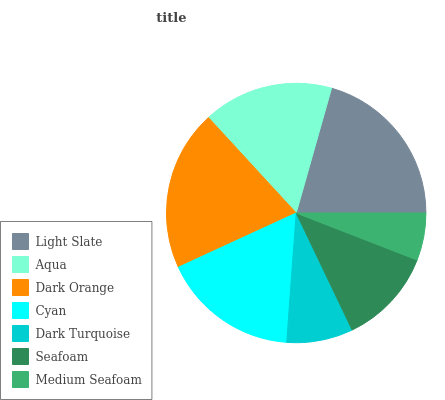Is Medium Seafoam the minimum?
Answer yes or no. Yes. Is Light Slate the maximum?
Answer yes or no. Yes. Is Aqua the minimum?
Answer yes or no. No. Is Aqua the maximum?
Answer yes or no. No. Is Light Slate greater than Aqua?
Answer yes or no. Yes. Is Aqua less than Light Slate?
Answer yes or no. Yes. Is Aqua greater than Light Slate?
Answer yes or no. No. Is Light Slate less than Aqua?
Answer yes or no. No. Is Aqua the high median?
Answer yes or no. Yes. Is Aqua the low median?
Answer yes or no. Yes. Is Light Slate the high median?
Answer yes or no. No. Is Dark Turquoise the low median?
Answer yes or no. No. 